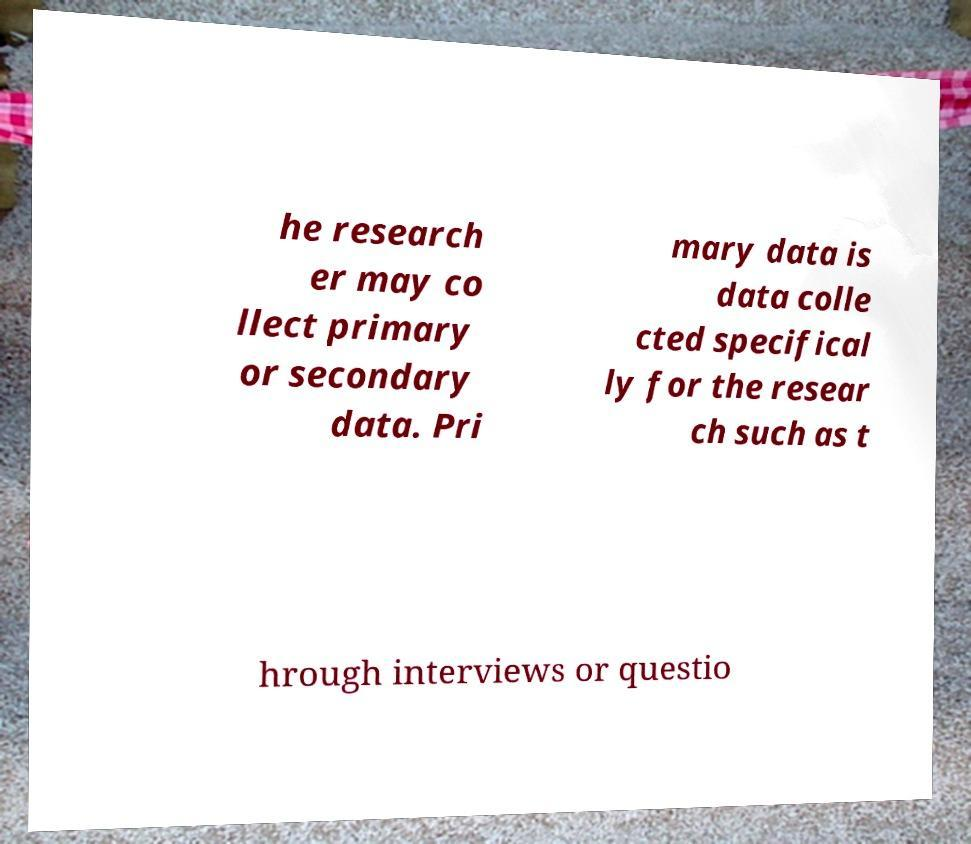Please read and relay the text visible in this image. What does it say? he research er may co llect primary or secondary data. Pri mary data is data colle cted specifical ly for the resear ch such as t hrough interviews or questio 